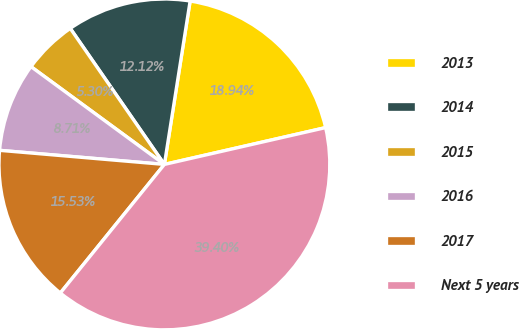Convert chart. <chart><loc_0><loc_0><loc_500><loc_500><pie_chart><fcel>2013<fcel>2014<fcel>2015<fcel>2016<fcel>2017<fcel>Next 5 years<nl><fcel>18.94%<fcel>12.12%<fcel>5.3%<fcel>8.71%<fcel>15.53%<fcel>39.4%<nl></chart> 